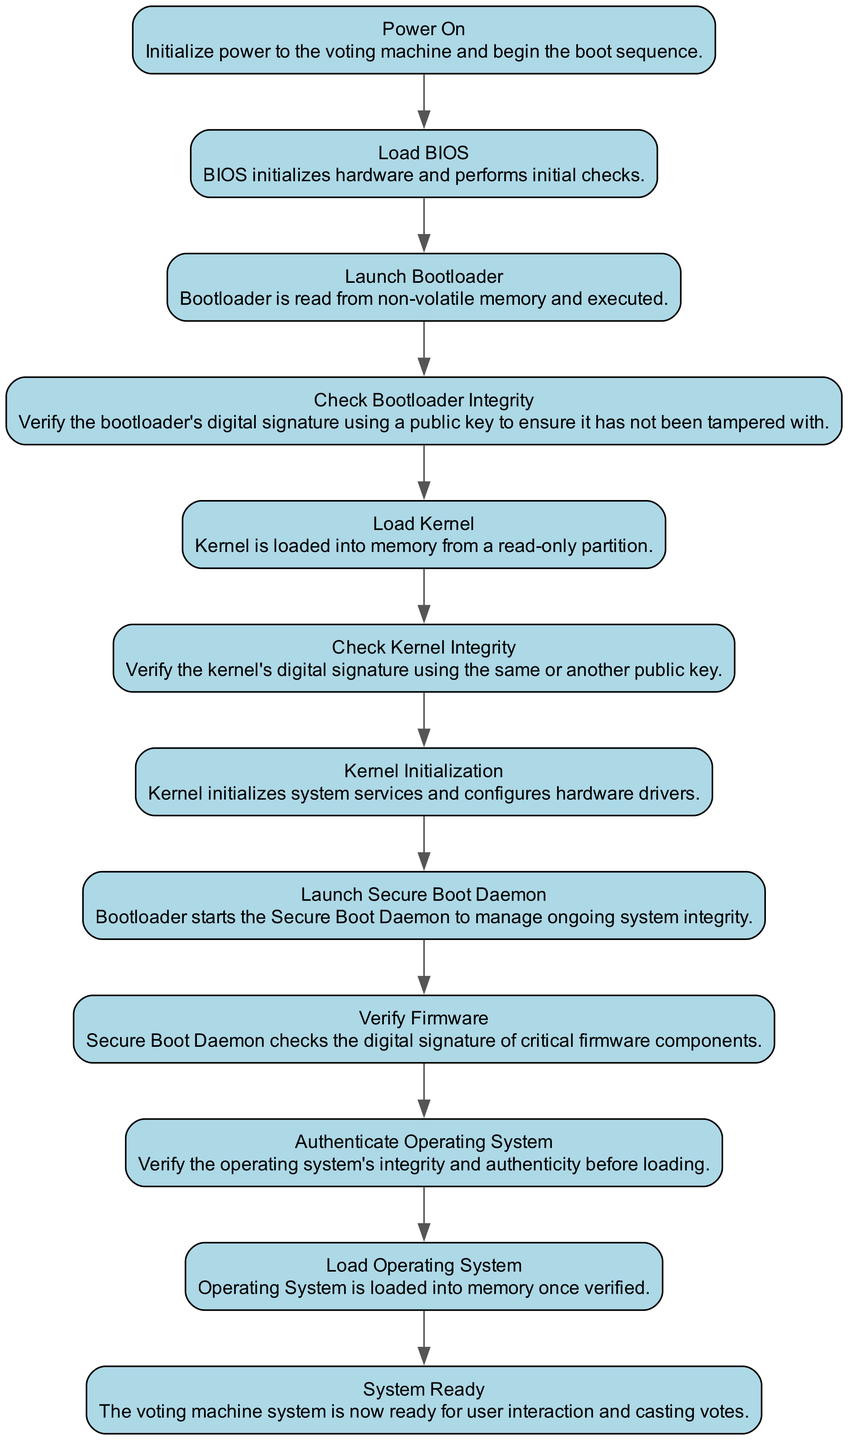What is the first step in the boot sequence? The diagram shows "Power On" as the first node, indicating that the process begins by initializing power to the voting machine.
Answer: Power On How many total nodes are present in the flowchart? Counting each step outlined in the diagram, there are 12 distinct nodes representing actions in the secure boot sequence.
Answer: 12 What action occurs after verifying the kernel's integrity? According to the flowchart, after the "Check Kernel Integrity," the next step is "Kernel Initialization."
Answer: Kernel Initialization What is the last step shown in the secure boot sequence? The diagram indicates that the final action in the process is "System Ready," meaning the voting machine is prepared for user interaction.
Answer: System Ready What is verified before loading the operating system? The flowchart specifies that the "Authenticate Operating System" step takes place before the operating system is loaded, ensuring its integrity and authenticity.
Answer: Authenticate Operating System Which component is responsible for managing ongoing system integrity? The diagram describes the "Secure Boot Daemon" as the entity that is launched to manage ongoing system integrity.
Answer: Secure Boot Daemon At what point is the kernel loaded into memory? From the flowchart, the kernel is loaded right after the "Load Kernel" step is executed, following the integrity check.
Answer: Load Kernel What is done to ensure the bootloader has not been tampered with? The diagram indicates that "Check Bootloader Integrity" is performed, where the digital signature of the bootloader is verified using a public key.
Answer: Check Bootloader Integrity What comes immediately after the "Launch Bootloader" step? The flowchart shows that immediately following the "Launch Bootloader," the system performs the "Check Bootloader Integrity" step.
Answer: Check Bootloader Integrity 